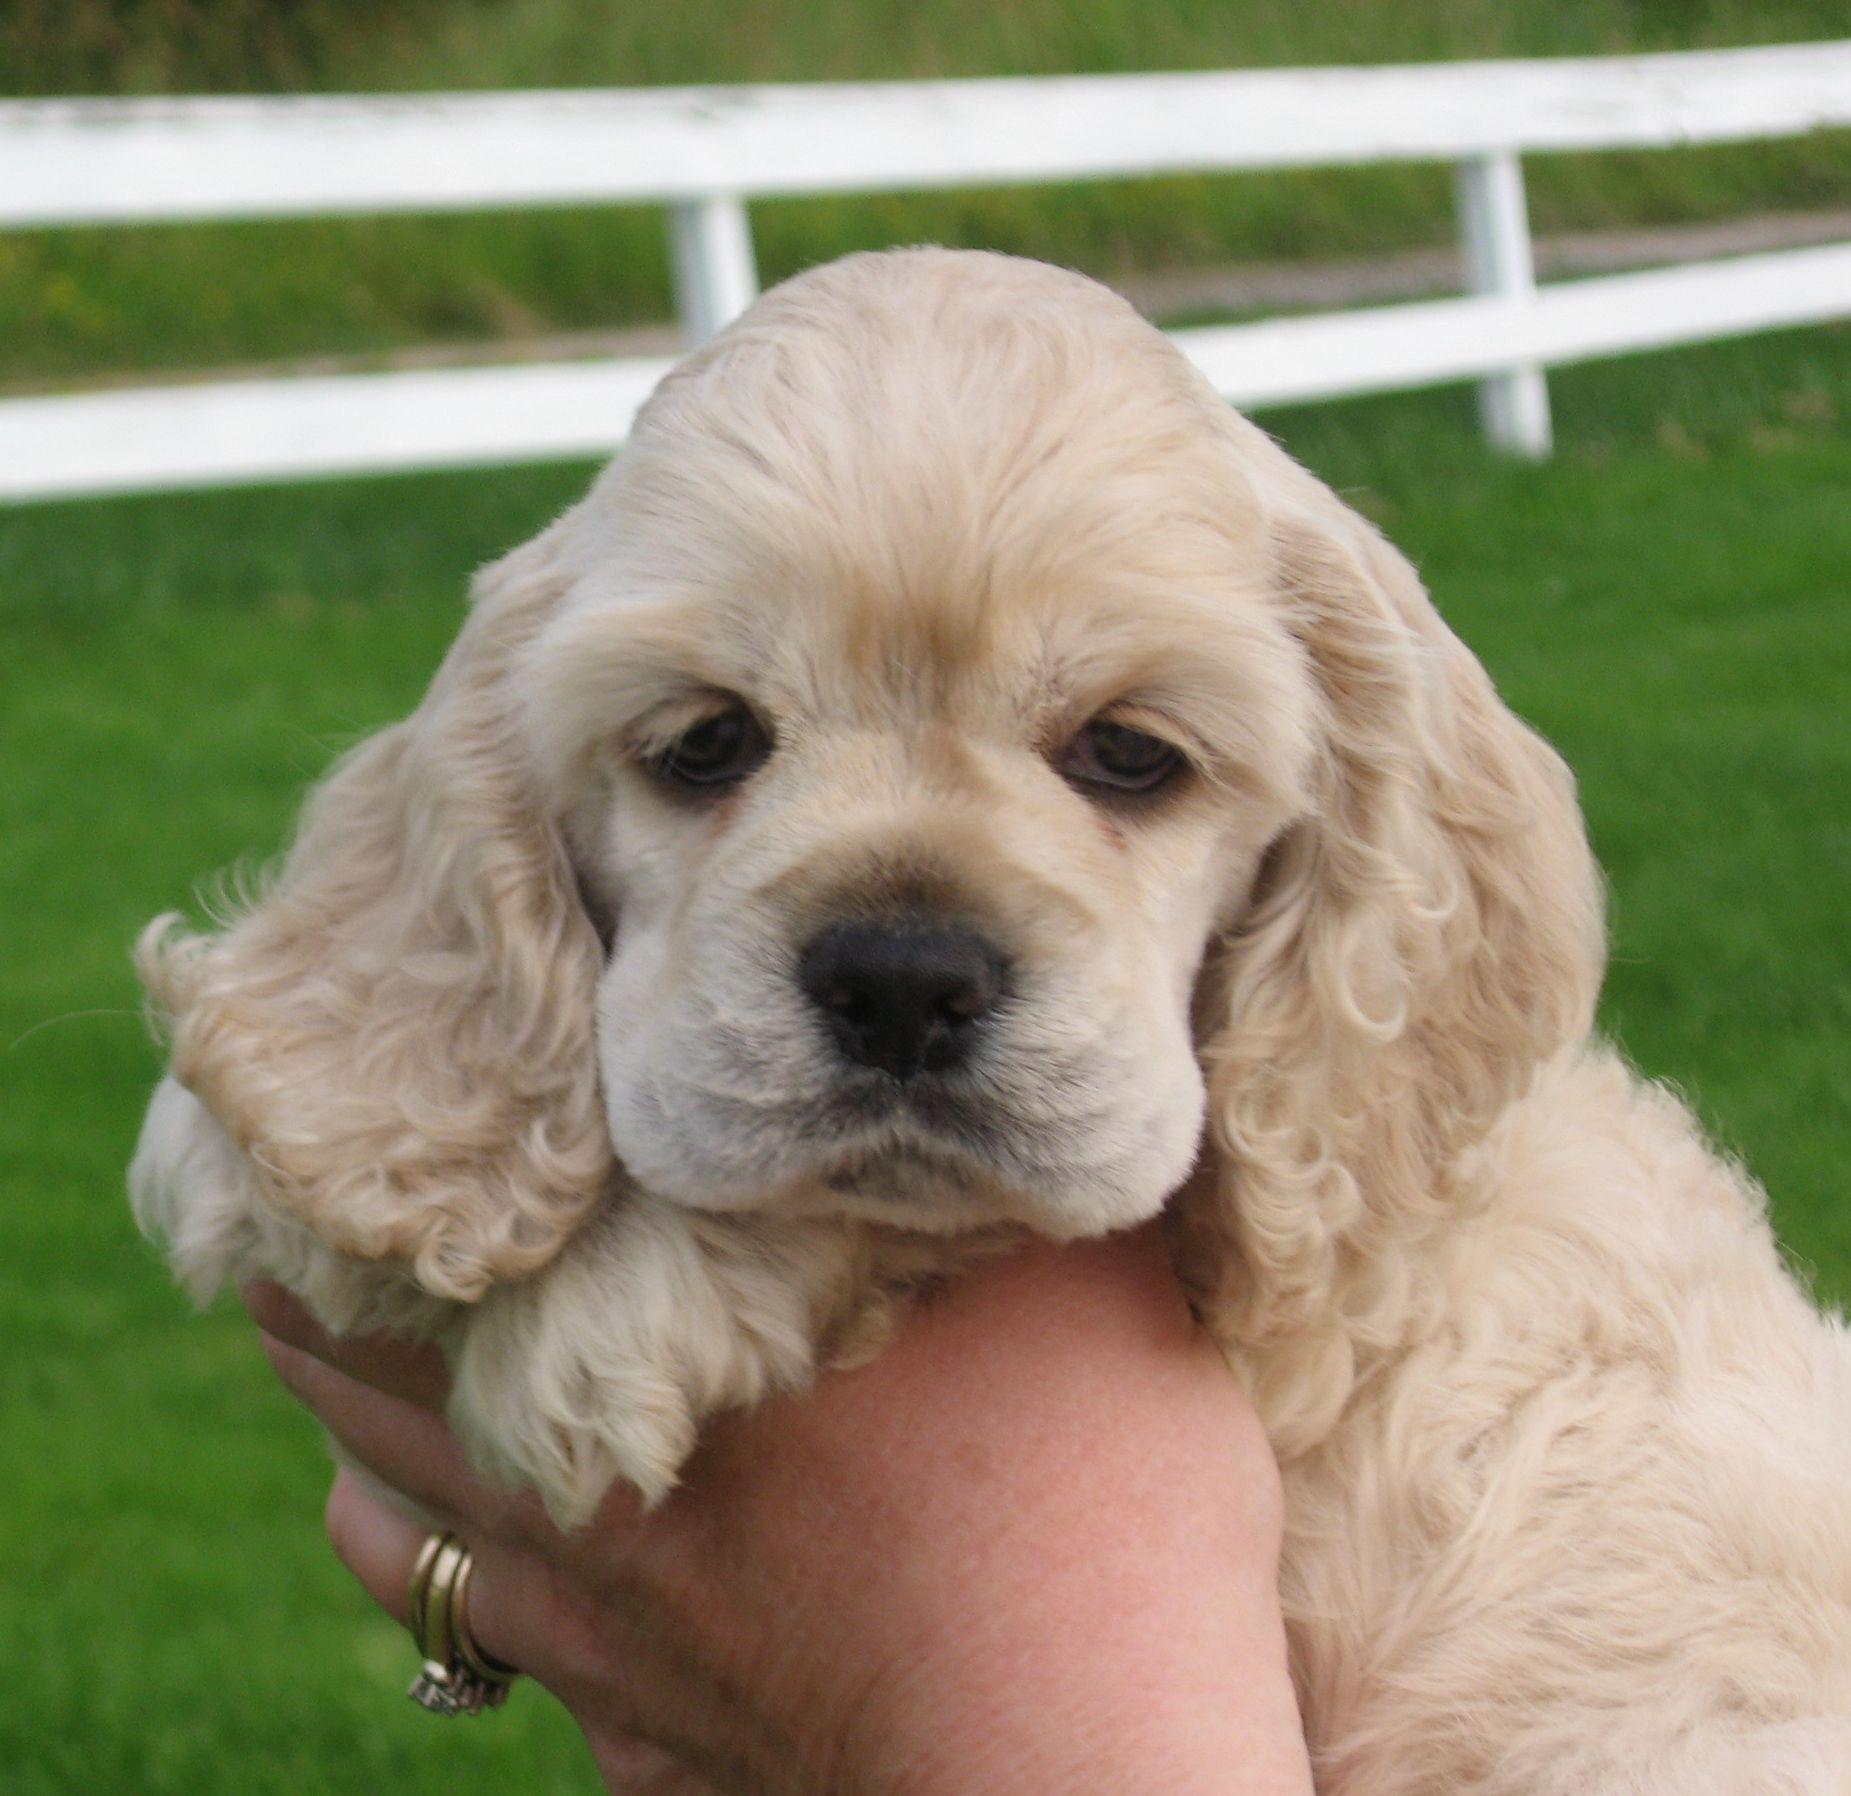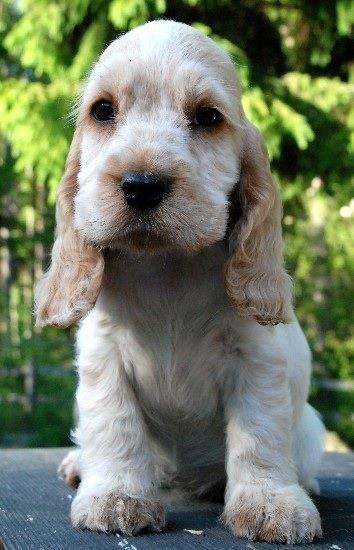The first image is the image on the left, the second image is the image on the right. Given the left and right images, does the statement "A hand is holding one spaniel in the left image, while the right image shows at least one spaniel sitting upright." hold true? Answer yes or no. Yes. The first image is the image on the left, the second image is the image on the right. Examine the images to the left and right. Is the description "In one of the two images the dog is being held in someone's hands." accurate? Answer yes or no. Yes. 